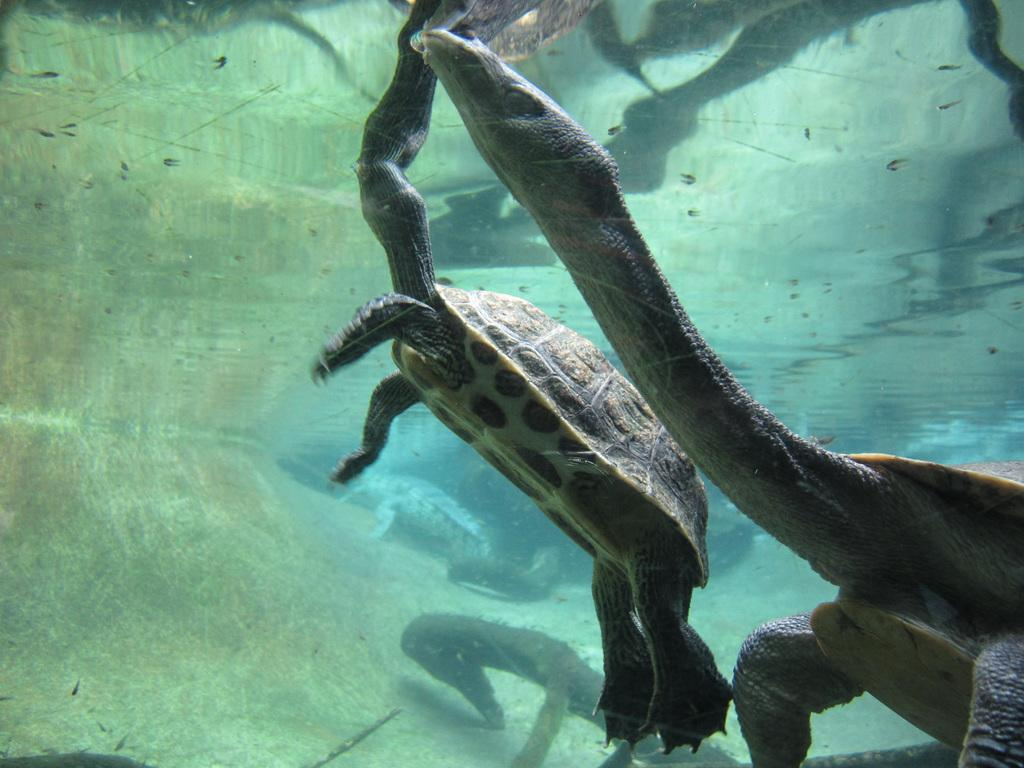How many tortoises are present in the image? There are four tortoises in the image. Where are the tortoises located in the image? The tortoises are in the water. What type of environment might the image be taken in? The image is likely taken in the ocean. What type of pump can be seen in the image? There is no pump present in the image. How many bodies are visible in the image? There are no bodies visible in the image; it features four tortoises in the water. What type of jelly can be seen floating in the water in the image? There is no jelly present in the image. 